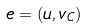Convert formula to latex. <formula><loc_0><loc_0><loc_500><loc_500>e = ( u , v _ { C } )</formula> 